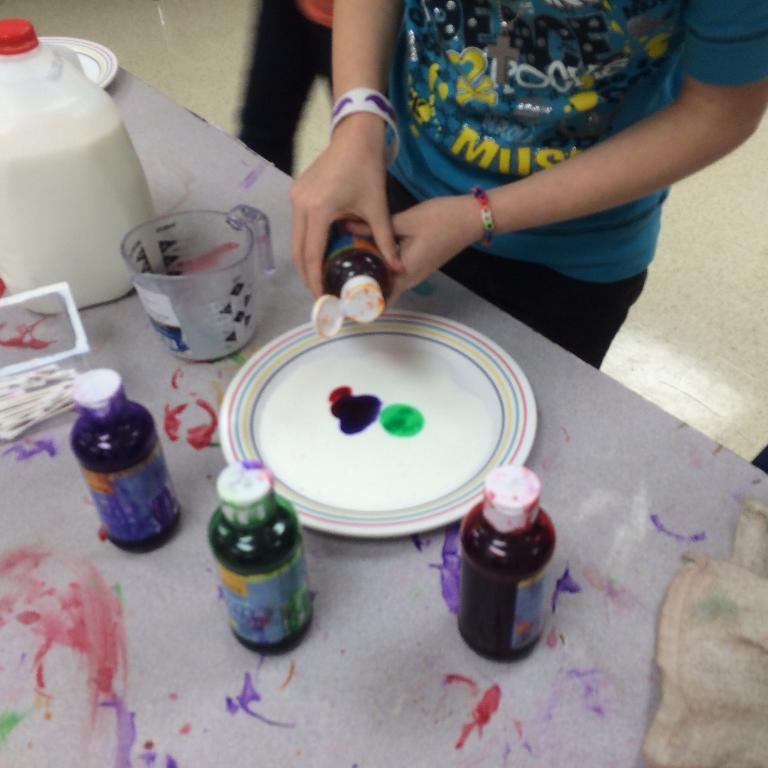What is the main piece of furniture in the image? There is a table in the image. What items can be seen on the table? There are bottles, plates, colors, a jug, and a can on the table. What is the lady in the image doing? The lady is standing in the image and holding a bottle. What type of cork can be seen in the image? There is no cork present in the image. How does the honey contribute to the scene in the image? There is no honey present in the image. 